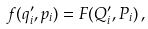<formula> <loc_0><loc_0><loc_500><loc_500>f ( q _ { i } ^ { \prime } , p _ { i } ) = F ( Q _ { i } ^ { \prime } , P _ { i } ) \, ,</formula> 